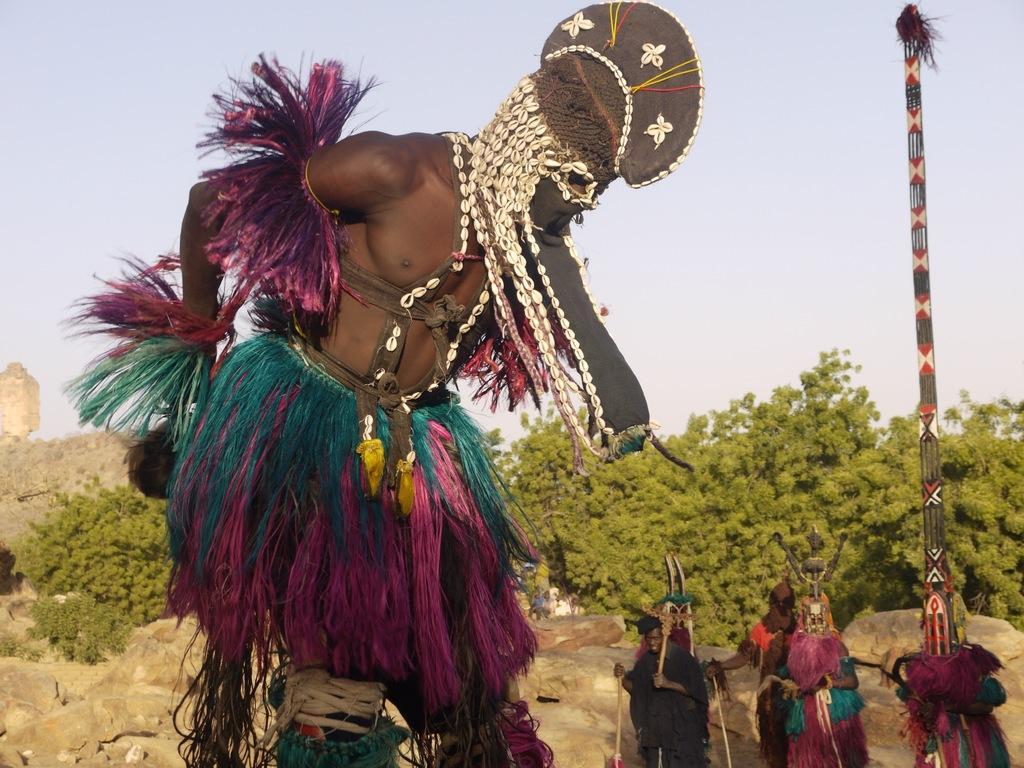Could you give a brief overview of what you see in this image? This is the picture of a person wearing a colorful dress and we can see a few people standing and carrying some objects. In the background, we can see trees and the stones and the sky. 